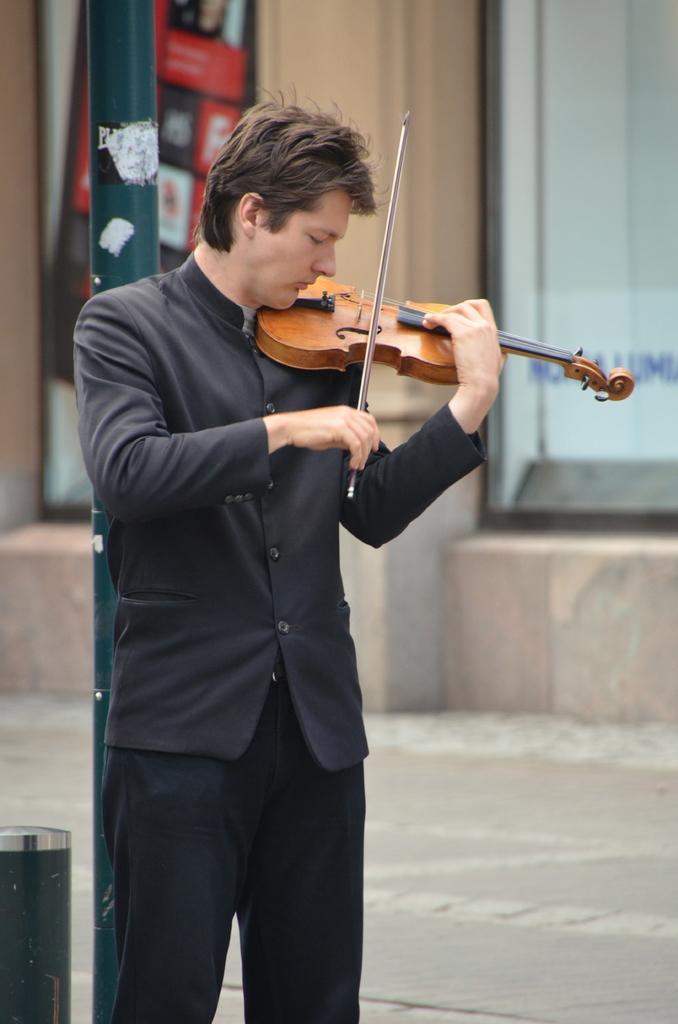How would you summarize this image in a sentence or two? He is standing and his playing a guitar. 